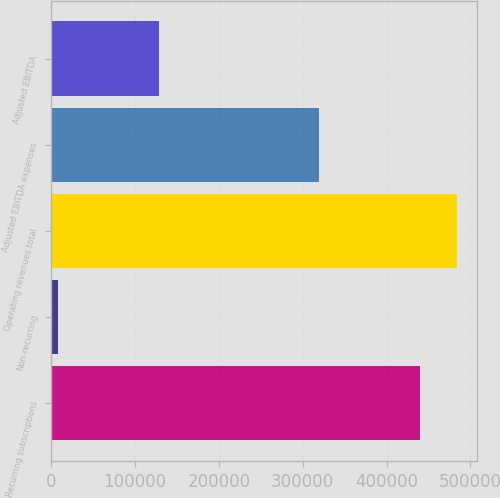<chart> <loc_0><loc_0><loc_500><loc_500><bar_chart><fcel>Recurring subscriptions<fcel>Non-recurring<fcel>Operating revenues total<fcel>Adjusted EBITDA expenses<fcel>Adjusted EBITDA<nl><fcel>439864<fcel>8489<fcel>483850<fcel>319846<fcel>128507<nl></chart> 